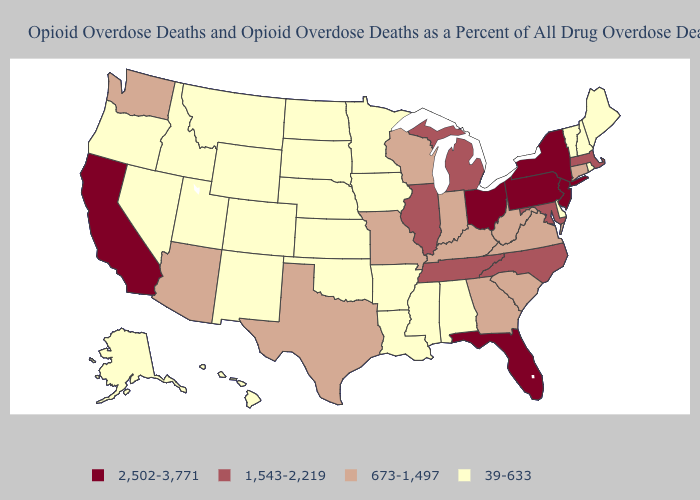Among the states that border Vermont , does New York have the lowest value?
Keep it brief. No. Which states have the lowest value in the West?
Answer briefly. Alaska, Colorado, Hawaii, Idaho, Montana, Nevada, New Mexico, Oregon, Utah, Wyoming. Does Utah have the lowest value in the USA?
Keep it brief. Yes. Does New York have the same value as Florida?
Write a very short answer. Yes. Does Tennessee have the highest value in the USA?
Answer briefly. No. Does the first symbol in the legend represent the smallest category?
Answer briefly. No. What is the lowest value in the USA?
Answer briefly. 39-633. What is the highest value in states that border Idaho?
Concise answer only. 673-1,497. What is the highest value in states that border West Virginia?
Concise answer only. 2,502-3,771. Does Ohio have the highest value in the MidWest?
Write a very short answer. Yes. Name the states that have a value in the range 1,543-2,219?
Concise answer only. Illinois, Maryland, Massachusetts, Michigan, North Carolina, Tennessee. What is the value of Kansas?
Concise answer only. 39-633. Name the states that have a value in the range 673-1,497?
Give a very brief answer. Arizona, Connecticut, Georgia, Indiana, Kentucky, Missouri, South Carolina, Texas, Virginia, Washington, West Virginia, Wisconsin. What is the lowest value in states that border Indiana?
Write a very short answer. 673-1,497. What is the lowest value in the USA?
Give a very brief answer. 39-633. 